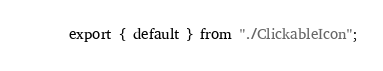<code> <loc_0><loc_0><loc_500><loc_500><_JavaScript_>export { default } from "./ClickableIcon";
</code> 